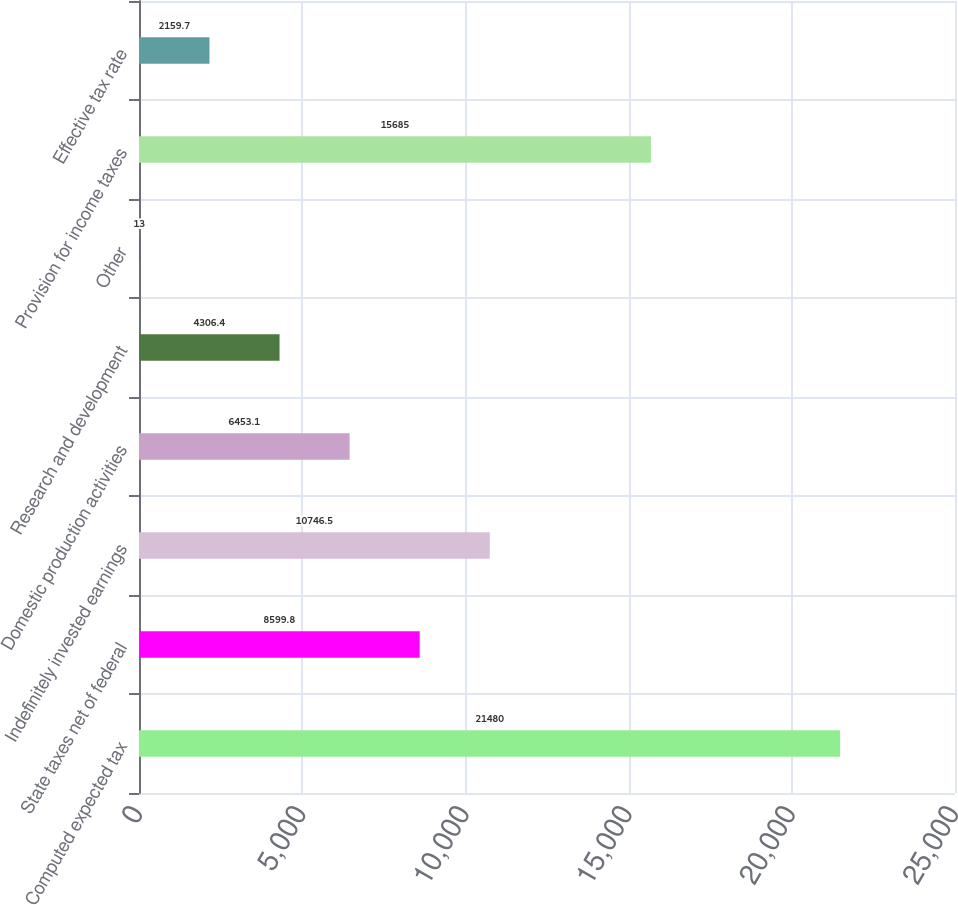Convert chart to OTSL. <chart><loc_0><loc_0><loc_500><loc_500><bar_chart><fcel>Computed expected tax<fcel>State taxes net of federal<fcel>Indefinitely invested earnings<fcel>Domestic production activities<fcel>Research and development<fcel>Other<fcel>Provision for income taxes<fcel>Effective tax rate<nl><fcel>21480<fcel>8599.8<fcel>10746.5<fcel>6453.1<fcel>4306.4<fcel>13<fcel>15685<fcel>2159.7<nl></chart> 